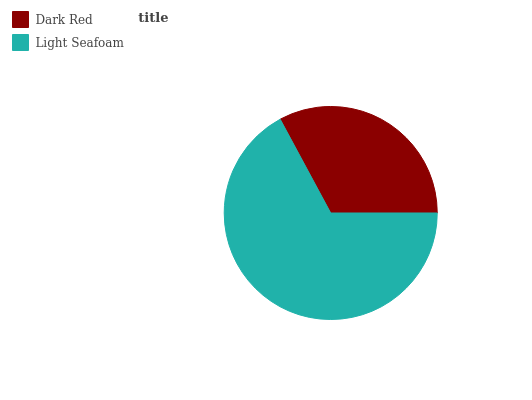Is Dark Red the minimum?
Answer yes or no. Yes. Is Light Seafoam the maximum?
Answer yes or no. Yes. Is Light Seafoam the minimum?
Answer yes or no. No. Is Light Seafoam greater than Dark Red?
Answer yes or no. Yes. Is Dark Red less than Light Seafoam?
Answer yes or no. Yes. Is Dark Red greater than Light Seafoam?
Answer yes or no. No. Is Light Seafoam less than Dark Red?
Answer yes or no. No. Is Light Seafoam the high median?
Answer yes or no. Yes. Is Dark Red the low median?
Answer yes or no. Yes. Is Dark Red the high median?
Answer yes or no. No. Is Light Seafoam the low median?
Answer yes or no. No. 